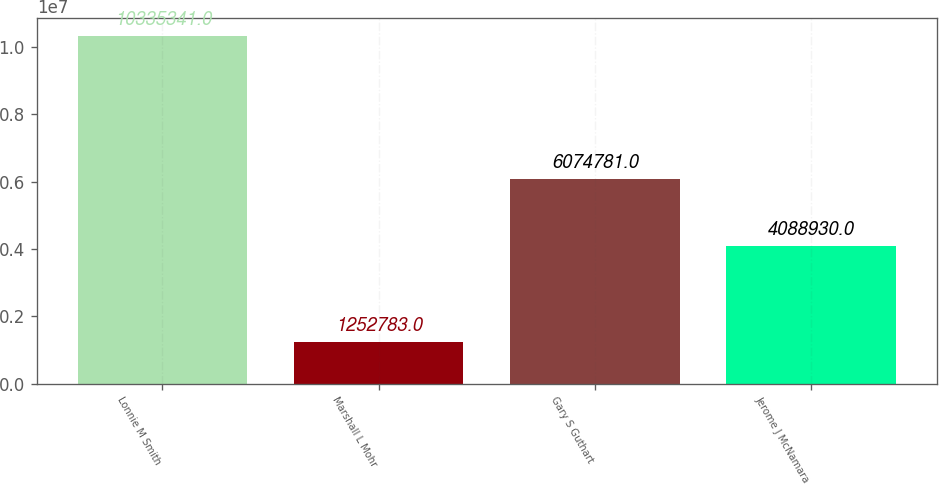Convert chart to OTSL. <chart><loc_0><loc_0><loc_500><loc_500><bar_chart><fcel>Lonnie M Smith<fcel>Marshall L Mohr<fcel>Gary S Guthart<fcel>Jerome J McNamara<nl><fcel>1.03353e+07<fcel>1.25278e+06<fcel>6.07478e+06<fcel>4.08893e+06<nl></chart> 